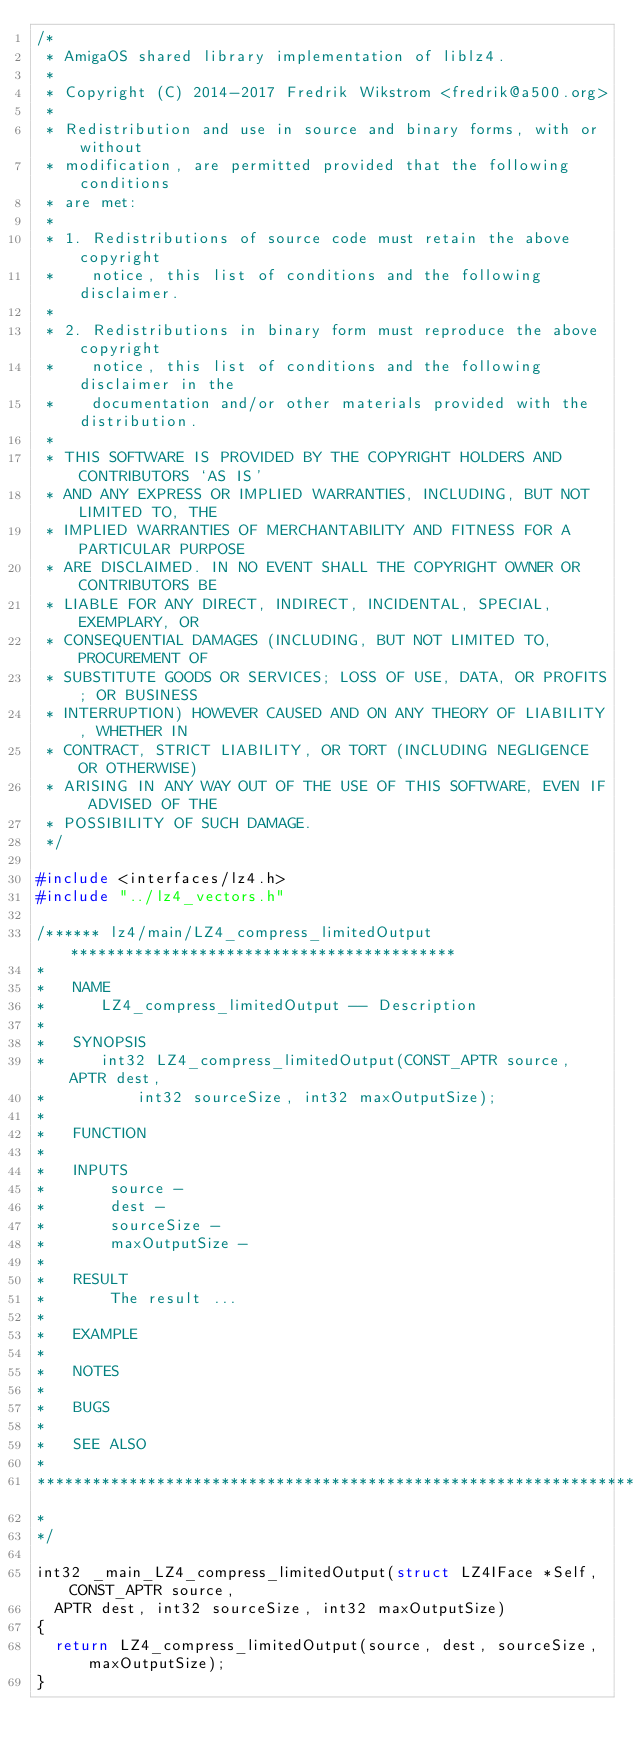<code> <loc_0><loc_0><loc_500><loc_500><_C_>/*
 * AmigaOS shared library implementation of liblz4.
 *
 * Copyright (C) 2014-2017 Fredrik Wikstrom <fredrik@a500.org>
 *
 * Redistribution and use in source and binary forms, with or without
 * modification, are permitted provided that the following conditions
 * are met:
 *
 * 1. Redistributions of source code must retain the above copyright
 *    notice, this list of conditions and the following disclaimer.
 *
 * 2. Redistributions in binary form must reproduce the above copyright
 *    notice, this list of conditions and the following disclaimer in the
 *    documentation and/or other materials provided with the distribution.
 *
 * THIS SOFTWARE IS PROVIDED BY THE COPYRIGHT HOLDERS AND CONTRIBUTORS `AS IS'
 * AND ANY EXPRESS OR IMPLIED WARRANTIES, INCLUDING, BUT NOT LIMITED TO, THE
 * IMPLIED WARRANTIES OF MERCHANTABILITY AND FITNESS FOR A PARTICULAR PURPOSE
 * ARE DISCLAIMED. IN NO EVENT SHALL THE COPYRIGHT OWNER OR CONTRIBUTORS BE
 * LIABLE FOR ANY DIRECT, INDIRECT, INCIDENTAL, SPECIAL, EXEMPLARY, OR
 * CONSEQUENTIAL DAMAGES (INCLUDING, BUT NOT LIMITED TO, PROCUREMENT OF
 * SUBSTITUTE GOODS OR SERVICES; LOSS OF USE, DATA, OR PROFITS; OR BUSINESS
 * INTERRUPTION) HOWEVER CAUSED AND ON ANY THEORY OF LIABILITY, WHETHER IN
 * CONTRACT, STRICT LIABILITY, OR TORT (INCLUDING NEGLIGENCE OR OTHERWISE)
 * ARISING IN ANY WAY OUT OF THE USE OF THIS SOFTWARE, EVEN IF ADVISED OF THE
 * POSSIBILITY OF SUCH DAMAGE.
 */

#include <interfaces/lz4.h>
#include "../lz4_vectors.h"

/****** lz4/main/LZ4_compress_limitedOutput ******************************************
*
*   NAME
*      LZ4_compress_limitedOutput -- Description
*
*   SYNOPSIS
*      int32 LZ4_compress_limitedOutput(CONST_APTR source, APTR dest, 
*          int32 sourceSize, int32 maxOutputSize);
*
*   FUNCTION
*
*   INPUTS
*       source - 
*       dest - 
*       sourceSize - 
*       maxOutputSize - 
*
*   RESULT
*       The result ...
*
*   EXAMPLE
*
*   NOTES
*
*   BUGS
*
*   SEE ALSO
*
*****************************************************************************
*
*/

int32 _main_LZ4_compress_limitedOutput(struct LZ4IFace *Self, CONST_APTR source,
	APTR dest, int32 sourceSize, int32 maxOutputSize)
{
	return LZ4_compress_limitedOutput(source, dest, sourceSize, maxOutputSize);
}

</code> 